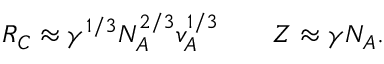<formula> <loc_0><loc_0><loc_500><loc_500>\begin{array} { r l r } { R _ { C } \approx \gamma ^ { 1 / 3 } N _ { A } ^ { 2 / 3 } v _ { A } ^ { 1 / 3 } } & { Z \approx \gamma N _ { A } . } \end{array}</formula> 